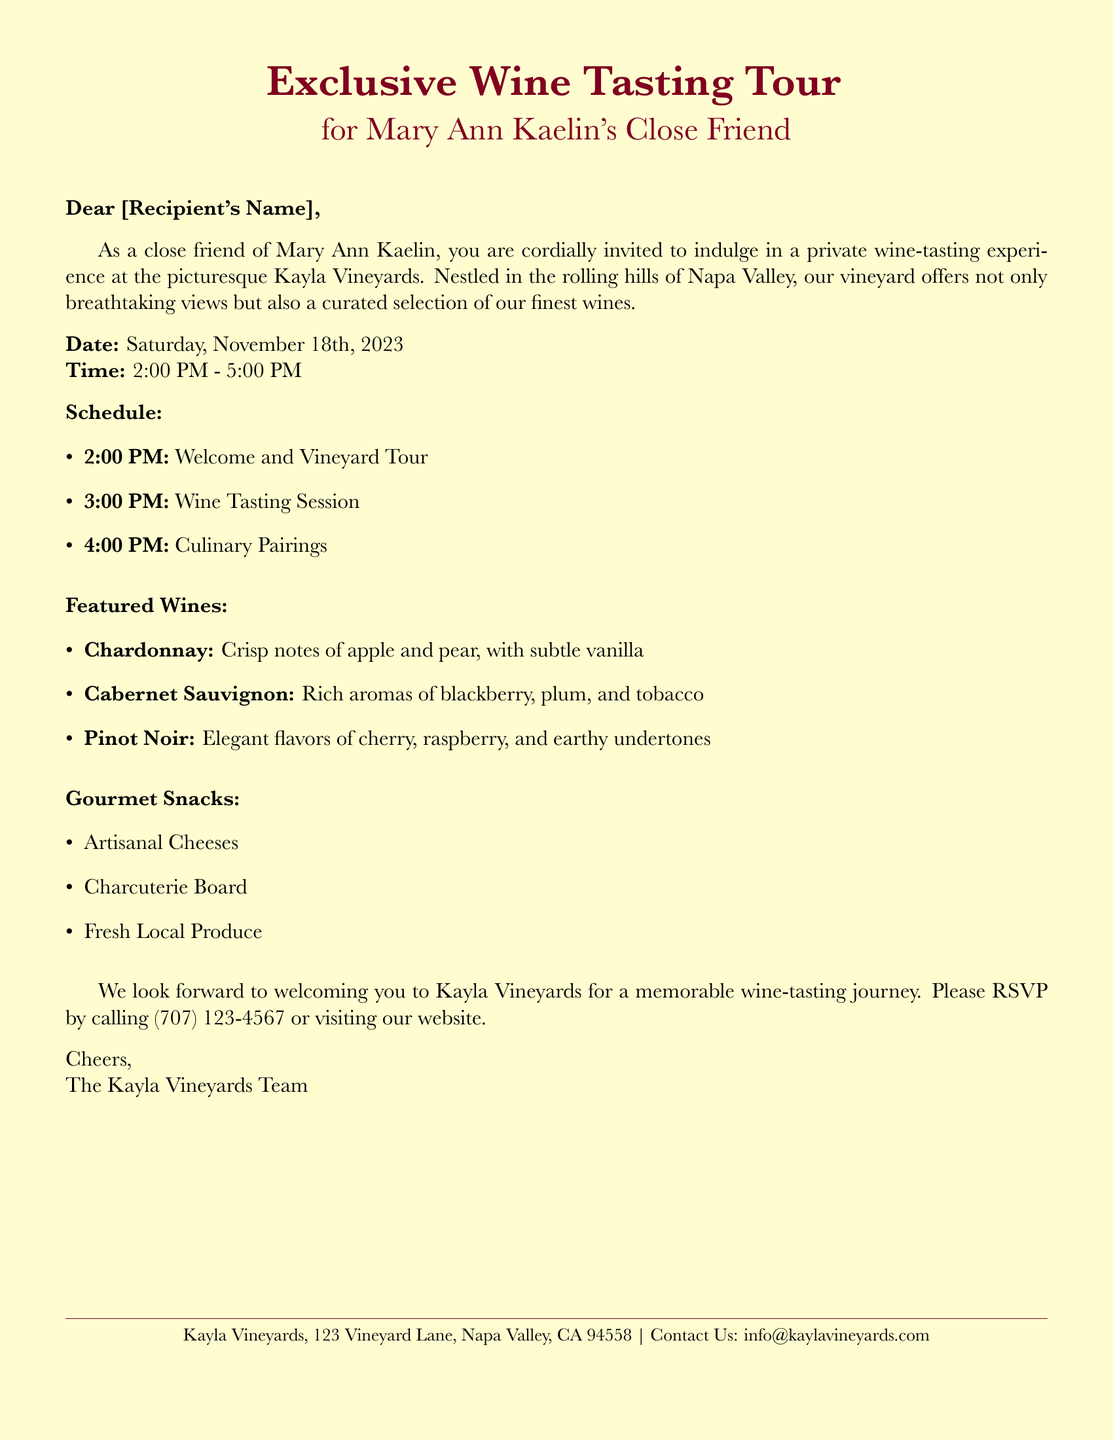What is the name of the vineyard? The document mentions the vineyard as Kayla Vineyards.
Answer: Kayla Vineyards What is the date of the wine tasting tour? The scheduled date for the wine tasting tour is clearly stated in the document.
Answer: November 18th, 2023 What time does the wine tasting session start? The wine tasting session is detailed in the schedule section of the document.
Answer: 3:00 PM What is one of the featured wines? The document lists several featured wines in the tasting.
Answer: Chardonnay What type of gourmet snacks will be provided? The document specifies the types of snacks included during the tasting.
Answer: Artisanal Cheeses What is the RSVP contact method? The document mentions how to RSVP for the event.
Answer: Calling What are the starting and ending times of the event? The document provides exact times for the event schedule.
Answer: 2:00 PM - 5:00 PM How is the invitation addressed? The document indicates how the invitation is specifically addressed.
Answer: For Mary Ann Kaelin's Close Friend What is the location of Kayla Vineyards? The document contains the address of Kayla Vineyards at the bottom.
Answer: 123 Vineyard Lane, Napa Valley, CA 94558 